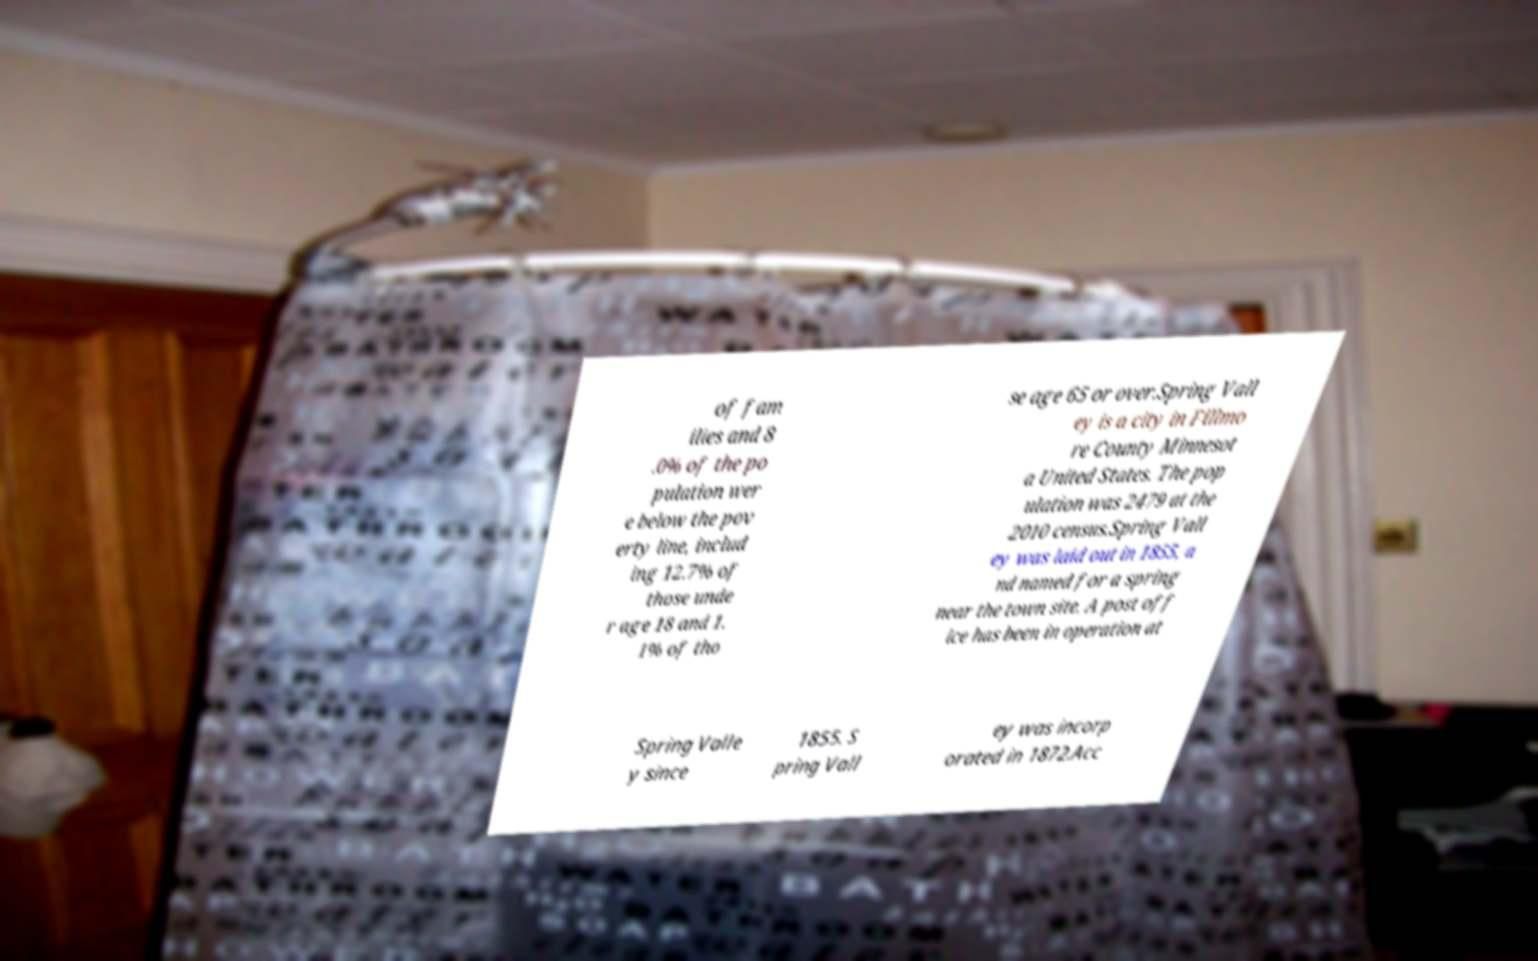There's text embedded in this image that I need extracted. Can you transcribe it verbatim? of fam ilies and 8 .0% of the po pulation wer e below the pov erty line, includ ing 12.7% of those unde r age 18 and 1. 1% of tho se age 65 or over.Spring Vall ey is a city in Fillmo re County Minnesot a United States. The pop ulation was 2479 at the 2010 census.Spring Vall ey was laid out in 1855, a nd named for a spring near the town site. A post off ice has been in operation at Spring Valle y since 1855. S pring Vall ey was incorp orated in 1872.Acc 